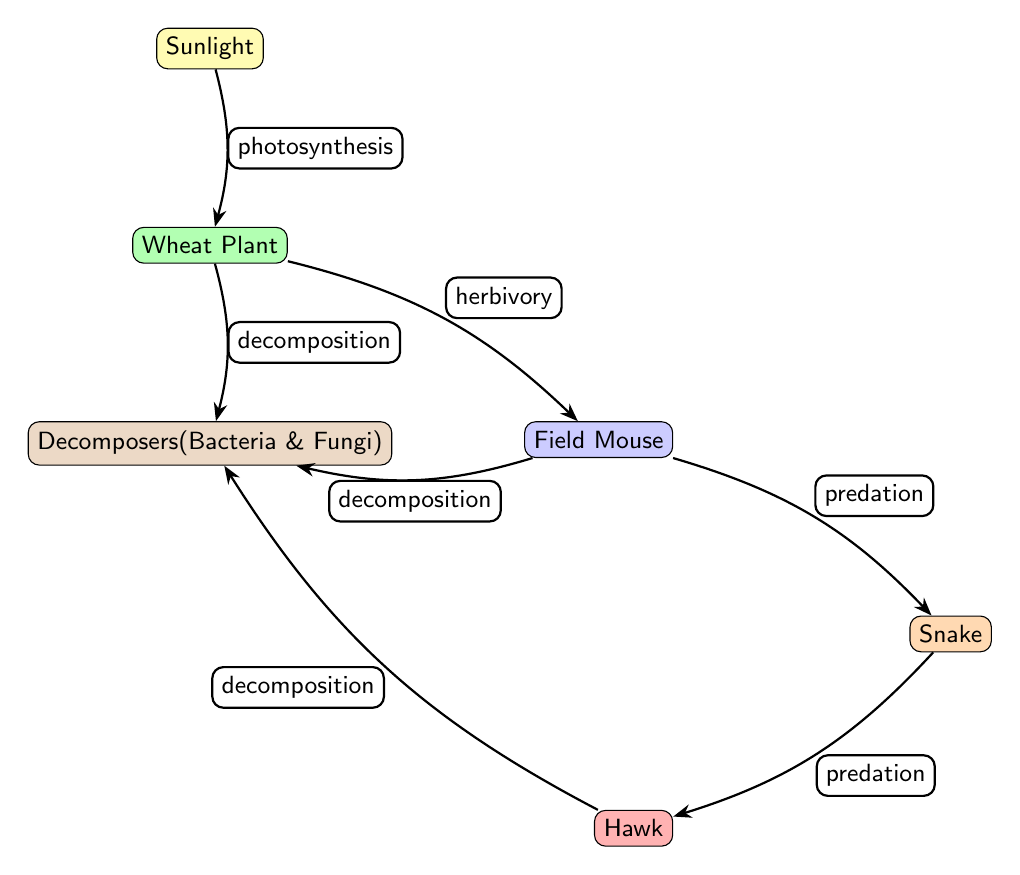What is the energy source in this food chain? The diagram clearly indicates that the energy source in this food chain is "Sunlight," which is represented as the top node.
Answer: Sunlight How many primary consumers are present in the diagram? By reviewing the nodes in the diagram, there is one primary consumer, which is the "Field Mouse," located below the producer.
Answer: 1 What type of relationship exists between the Wheat Plant and the Field Mouse? The arrow from the Wheat Plant to the Field Mouse indicates a "herbivory" relationship, meaning the Field Mouse feeds on the Wheat Plant.
Answer: herbivory Which organism is at the top of this food chain? The topmost organism in the food chain is the "Hawk," which is located at a higher position in the diagram compared to other consumers.
Answer: Hawk What is the role of Decomposers in this food chain? Decomposers, represented by "Bacteria & Fungi," play the role of breaking down organic matter, as indicated by the arrows pointing from multiple organisms to them for "decomposition."
Answer: decomposition What is the relationship type between the Snake and the Hawk? The diagram shows an arrow pointing from the Snake to the Hawk, labeled "predation," indicating that the Hawk preys on the Snake.
Answer: predation How many edges are present in the diagram? By counting the arrows that represent the relationships between nodes, there are five distinct arrows connecting them, indicating the interactions of the food chain.
Answer: 5 Which organisms contribute to decomposition? The diagram indicates that the organisms contributing to decomposition include the Wheat Plant, Field Mouse, and Snake, all pointing towards Decomposers ("Bacteria & Fungi").
Answer: Wheat Plant, Field Mouse, Snake What are the levels of consumers in this food chain? The diagram presents three levels of consumers: primary (Field Mouse), secondary (Snake), and tertiary (Hawk), indicating that each level represents a different position in the food chain.
Answer: primary, secondary, tertiary 